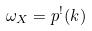Convert formula to latex. <formula><loc_0><loc_0><loc_500><loc_500>\omega _ { X } = p ^ { ! } ( k )</formula> 